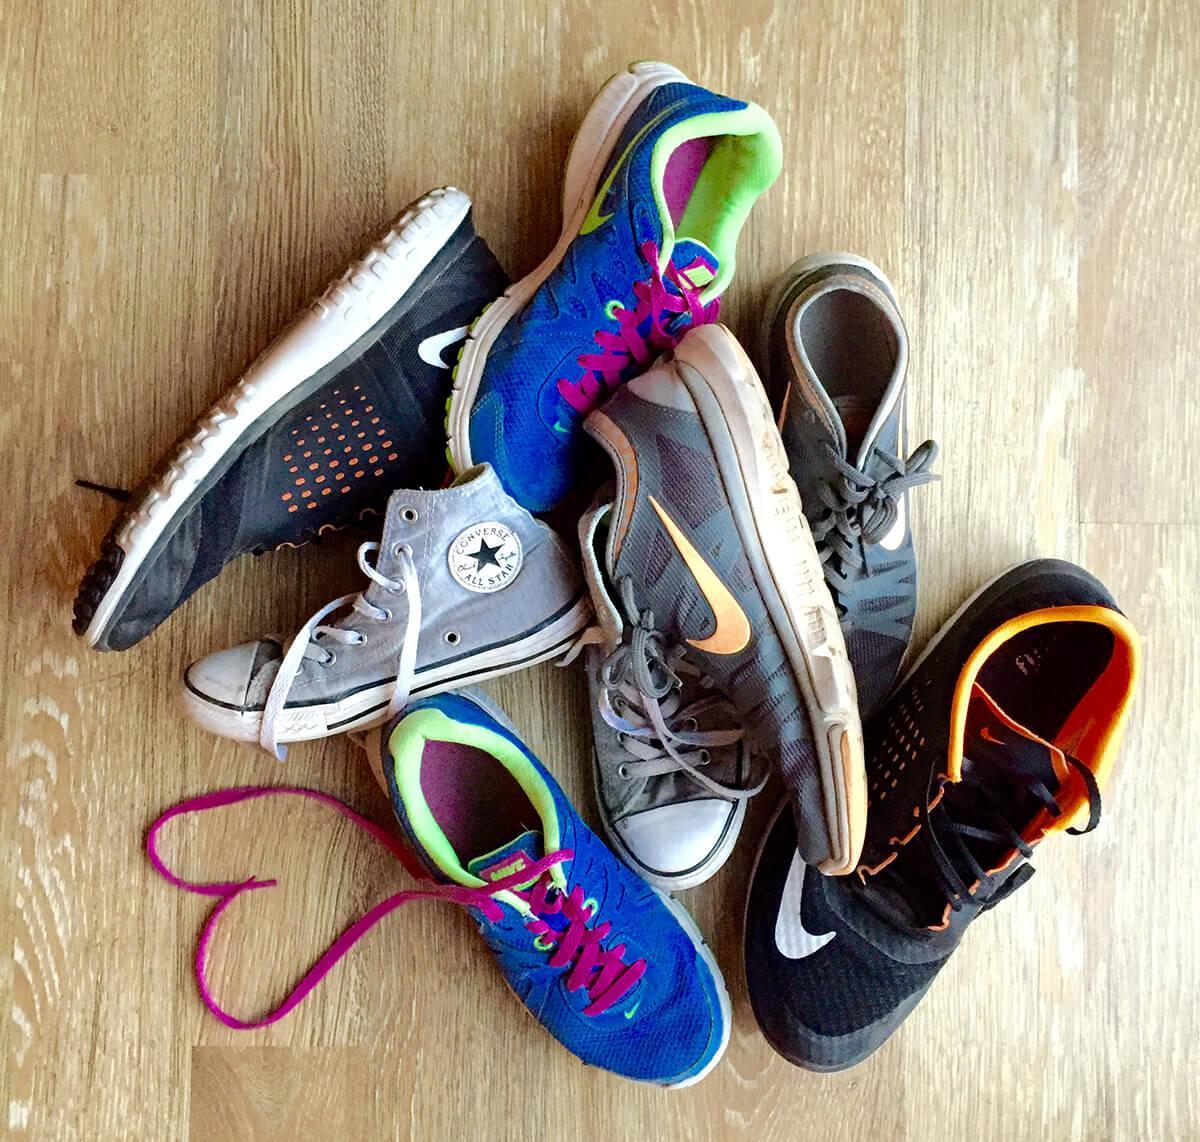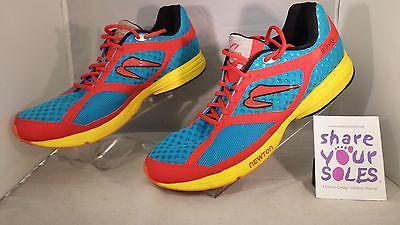The first image is the image on the left, the second image is the image on the right. Considering the images on both sides, is "The left image contains at least five shoes." valid? Answer yes or no. Yes. 